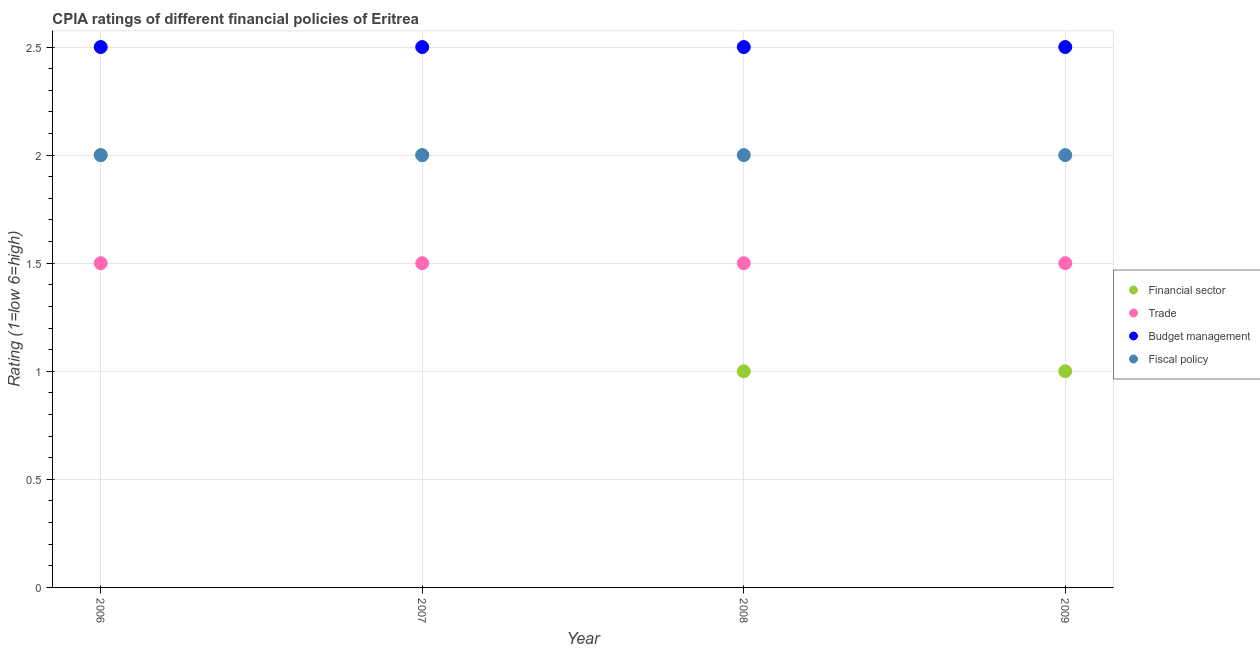In which year was the cpia rating of budget management maximum?
Provide a short and direct response. 2006. In which year was the cpia rating of trade minimum?
Ensure brevity in your answer.  2006. What is the difference between the cpia rating of trade in 2008 and that in 2009?
Your answer should be very brief. 0. What is the average cpia rating of financial sector per year?
Make the answer very short. 1.5. Is the cpia rating of trade in 2008 less than that in 2009?
Provide a short and direct response. No. Is the difference between the cpia rating of financial sector in 2008 and 2009 greater than the difference between the cpia rating of fiscal policy in 2008 and 2009?
Provide a succinct answer. No. What is the difference between the highest and the second highest cpia rating of financial sector?
Ensure brevity in your answer.  0. Is the sum of the cpia rating of fiscal policy in 2007 and 2008 greater than the maximum cpia rating of budget management across all years?
Provide a short and direct response. Yes. Is it the case that in every year, the sum of the cpia rating of financial sector and cpia rating of trade is greater than the cpia rating of budget management?
Your answer should be compact. No. Does the cpia rating of fiscal policy monotonically increase over the years?
Your response must be concise. No. Is the cpia rating of financial sector strictly greater than the cpia rating of trade over the years?
Offer a terse response. No. Is the cpia rating of fiscal policy strictly less than the cpia rating of budget management over the years?
Your answer should be very brief. Yes. How many dotlines are there?
Offer a terse response. 4. How many years are there in the graph?
Offer a very short reply. 4. What is the difference between two consecutive major ticks on the Y-axis?
Your response must be concise. 0.5. Are the values on the major ticks of Y-axis written in scientific E-notation?
Give a very brief answer. No. Does the graph contain any zero values?
Your answer should be compact. No. What is the title of the graph?
Ensure brevity in your answer.  CPIA ratings of different financial policies of Eritrea. What is the Rating (1=low 6=high) of Trade in 2006?
Your response must be concise. 1.5. What is the Rating (1=low 6=high) in Fiscal policy in 2006?
Provide a short and direct response. 2. What is the Rating (1=low 6=high) in Fiscal policy in 2007?
Offer a very short reply. 2. What is the Rating (1=low 6=high) of Financial sector in 2008?
Give a very brief answer. 1. What is the Rating (1=low 6=high) of Budget management in 2008?
Ensure brevity in your answer.  2.5. What is the Rating (1=low 6=high) of Fiscal policy in 2008?
Keep it short and to the point. 2. What is the Rating (1=low 6=high) of Trade in 2009?
Offer a very short reply. 1.5. What is the Rating (1=low 6=high) in Budget management in 2009?
Your answer should be very brief. 2.5. Across all years, what is the maximum Rating (1=low 6=high) of Financial sector?
Make the answer very short. 2. Across all years, what is the minimum Rating (1=low 6=high) in Fiscal policy?
Keep it short and to the point. 2. What is the total Rating (1=low 6=high) in Financial sector in the graph?
Give a very brief answer. 6. What is the total Rating (1=low 6=high) of Fiscal policy in the graph?
Ensure brevity in your answer.  8. What is the difference between the Rating (1=low 6=high) in Trade in 2006 and that in 2007?
Make the answer very short. 0. What is the difference between the Rating (1=low 6=high) in Budget management in 2006 and that in 2007?
Make the answer very short. 0. What is the difference between the Rating (1=low 6=high) of Financial sector in 2006 and that in 2008?
Ensure brevity in your answer.  1. What is the difference between the Rating (1=low 6=high) of Budget management in 2006 and that in 2008?
Offer a terse response. 0. What is the difference between the Rating (1=low 6=high) of Fiscal policy in 2006 and that in 2008?
Provide a short and direct response. 0. What is the difference between the Rating (1=low 6=high) of Budget management in 2006 and that in 2009?
Give a very brief answer. 0. What is the difference between the Rating (1=low 6=high) in Fiscal policy in 2006 and that in 2009?
Offer a terse response. 0. What is the difference between the Rating (1=low 6=high) of Financial sector in 2007 and that in 2008?
Offer a very short reply. 1. What is the difference between the Rating (1=low 6=high) in Financial sector in 2007 and that in 2009?
Keep it short and to the point. 1. What is the difference between the Rating (1=low 6=high) of Trade in 2007 and that in 2009?
Provide a succinct answer. 0. What is the difference between the Rating (1=low 6=high) in Financial sector in 2008 and that in 2009?
Provide a short and direct response. 0. What is the difference between the Rating (1=low 6=high) of Trade in 2008 and that in 2009?
Your answer should be very brief. 0. What is the difference between the Rating (1=low 6=high) in Budget management in 2008 and that in 2009?
Offer a very short reply. 0. What is the difference between the Rating (1=low 6=high) of Fiscal policy in 2008 and that in 2009?
Your answer should be very brief. 0. What is the difference between the Rating (1=low 6=high) of Financial sector in 2006 and the Rating (1=low 6=high) of Trade in 2007?
Offer a terse response. 0.5. What is the difference between the Rating (1=low 6=high) in Trade in 2006 and the Rating (1=low 6=high) in Budget management in 2007?
Offer a very short reply. -1. What is the difference between the Rating (1=low 6=high) in Trade in 2006 and the Rating (1=low 6=high) in Fiscal policy in 2007?
Offer a terse response. -0.5. What is the difference between the Rating (1=low 6=high) of Trade in 2006 and the Rating (1=low 6=high) of Budget management in 2008?
Your answer should be compact. -1. What is the difference between the Rating (1=low 6=high) of Financial sector in 2006 and the Rating (1=low 6=high) of Fiscal policy in 2009?
Keep it short and to the point. 0. What is the difference between the Rating (1=low 6=high) of Trade in 2006 and the Rating (1=low 6=high) of Budget management in 2009?
Keep it short and to the point. -1. What is the difference between the Rating (1=low 6=high) of Trade in 2006 and the Rating (1=low 6=high) of Fiscal policy in 2009?
Offer a terse response. -0.5. What is the difference between the Rating (1=low 6=high) of Budget management in 2006 and the Rating (1=low 6=high) of Fiscal policy in 2009?
Give a very brief answer. 0.5. What is the difference between the Rating (1=low 6=high) in Financial sector in 2007 and the Rating (1=low 6=high) in Trade in 2008?
Keep it short and to the point. 0.5. What is the difference between the Rating (1=low 6=high) of Financial sector in 2007 and the Rating (1=low 6=high) of Budget management in 2008?
Provide a short and direct response. -0.5. What is the difference between the Rating (1=low 6=high) in Financial sector in 2007 and the Rating (1=low 6=high) in Fiscal policy in 2008?
Provide a succinct answer. 0. What is the difference between the Rating (1=low 6=high) in Trade in 2007 and the Rating (1=low 6=high) in Budget management in 2008?
Give a very brief answer. -1. What is the difference between the Rating (1=low 6=high) in Budget management in 2007 and the Rating (1=low 6=high) in Fiscal policy in 2008?
Offer a terse response. 0.5. What is the difference between the Rating (1=low 6=high) in Financial sector in 2007 and the Rating (1=low 6=high) in Budget management in 2009?
Your answer should be compact. -0.5. What is the difference between the Rating (1=low 6=high) in Trade in 2007 and the Rating (1=low 6=high) in Budget management in 2009?
Your answer should be compact. -1. What is the difference between the Rating (1=low 6=high) in Trade in 2007 and the Rating (1=low 6=high) in Fiscal policy in 2009?
Your response must be concise. -0.5. What is the difference between the Rating (1=low 6=high) in Budget management in 2007 and the Rating (1=low 6=high) in Fiscal policy in 2009?
Your answer should be compact. 0.5. What is the difference between the Rating (1=low 6=high) of Financial sector in 2008 and the Rating (1=low 6=high) of Trade in 2009?
Make the answer very short. -0.5. What is the difference between the Rating (1=low 6=high) of Trade in 2008 and the Rating (1=low 6=high) of Budget management in 2009?
Keep it short and to the point. -1. What is the difference between the Rating (1=low 6=high) of Trade in 2008 and the Rating (1=low 6=high) of Fiscal policy in 2009?
Ensure brevity in your answer.  -0.5. What is the average Rating (1=low 6=high) of Financial sector per year?
Make the answer very short. 1.5. What is the average Rating (1=low 6=high) of Fiscal policy per year?
Offer a terse response. 2. In the year 2006, what is the difference between the Rating (1=low 6=high) in Trade and Rating (1=low 6=high) in Budget management?
Offer a terse response. -1. In the year 2006, what is the difference between the Rating (1=low 6=high) in Trade and Rating (1=low 6=high) in Fiscal policy?
Provide a short and direct response. -0.5. In the year 2006, what is the difference between the Rating (1=low 6=high) in Budget management and Rating (1=low 6=high) in Fiscal policy?
Provide a short and direct response. 0.5. In the year 2007, what is the difference between the Rating (1=low 6=high) of Financial sector and Rating (1=low 6=high) of Trade?
Your answer should be compact. 0.5. In the year 2007, what is the difference between the Rating (1=low 6=high) in Financial sector and Rating (1=low 6=high) in Budget management?
Provide a succinct answer. -0.5. In the year 2007, what is the difference between the Rating (1=low 6=high) of Financial sector and Rating (1=low 6=high) of Fiscal policy?
Your answer should be compact. 0. In the year 2007, what is the difference between the Rating (1=low 6=high) in Trade and Rating (1=low 6=high) in Budget management?
Your answer should be compact. -1. In the year 2007, what is the difference between the Rating (1=low 6=high) in Trade and Rating (1=low 6=high) in Fiscal policy?
Your response must be concise. -0.5. In the year 2008, what is the difference between the Rating (1=low 6=high) in Budget management and Rating (1=low 6=high) in Fiscal policy?
Keep it short and to the point. 0.5. In the year 2009, what is the difference between the Rating (1=low 6=high) in Financial sector and Rating (1=low 6=high) in Budget management?
Your answer should be compact. -1.5. In the year 2009, what is the difference between the Rating (1=low 6=high) of Financial sector and Rating (1=low 6=high) of Fiscal policy?
Provide a succinct answer. -1. What is the ratio of the Rating (1=low 6=high) of Trade in 2006 to that in 2007?
Your answer should be very brief. 1. What is the ratio of the Rating (1=low 6=high) in Budget management in 2006 to that in 2007?
Offer a terse response. 1. What is the ratio of the Rating (1=low 6=high) in Fiscal policy in 2006 to that in 2007?
Your answer should be compact. 1. What is the ratio of the Rating (1=low 6=high) in Trade in 2006 to that in 2008?
Offer a terse response. 1. What is the ratio of the Rating (1=low 6=high) of Financial sector in 2006 to that in 2009?
Your response must be concise. 2. What is the ratio of the Rating (1=low 6=high) in Trade in 2006 to that in 2009?
Provide a short and direct response. 1. What is the ratio of the Rating (1=low 6=high) of Financial sector in 2007 to that in 2008?
Offer a very short reply. 2. What is the ratio of the Rating (1=low 6=high) in Trade in 2007 to that in 2008?
Provide a succinct answer. 1. What is the ratio of the Rating (1=low 6=high) of Fiscal policy in 2007 to that in 2008?
Your response must be concise. 1. What is the ratio of the Rating (1=low 6=high) in Trade in 2007 to that in 2009?
Your answer should be compact. 1. What is the ratio of the Rating (1=low 6=high) in Fiscal policy in 2007 to that in 2009?
Give a very brief answer. 1. What is the ratio of the Rating (1=low 6=high) of Financial sector in 2008 to that in 2009?
Your answer should be very brief. 1. What is the ratio of the Rating (1=low 6=high) of Trade in 2008 to that in 2009?
Your response must be concise. 1. What is the ratio of the Rating (1=low 6=high) in Fiscal policy in 2008 to that in 2009?
Your answer should be very brief. 1. What is the difference between the highest and the second highest Rating (1=low 6=high) in Financial sector?
Give a very brief answer. 0. What is the difference between the highest and the lowest Rating (1=low 6=high) in Trade?
Your response must be concise. 0. What is the difference between the highest and the lowest Rating (1=low 6=high) in Budget management?
Provide a short and direct response. 0. 